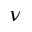<formula> <loc_0><loc_0><loc_500><loc_500>\nu</formula> 